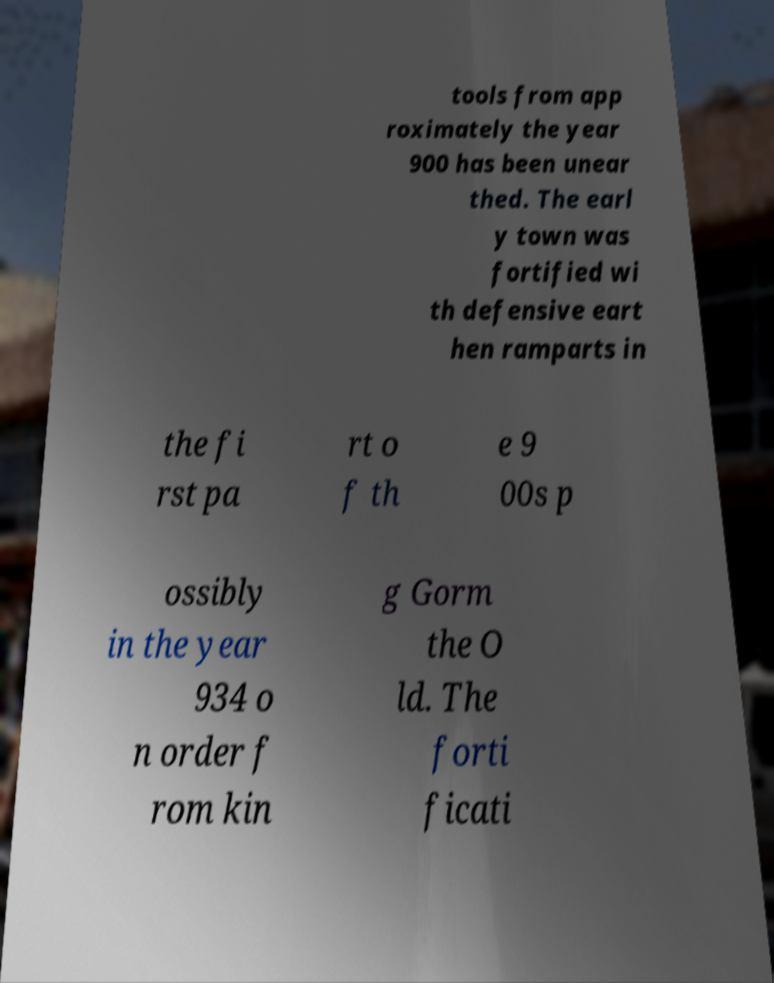Could you extract and type out the text from this image? tools from app roximately the year 900 has been unear thed. The earl y town was fortified wi th defensive eart hen ramparts in the fi rst pa rt o f th e 9 00s p ossibly in the year 934 o n order f rom kin g Gorm the O ld. The forti ficati 